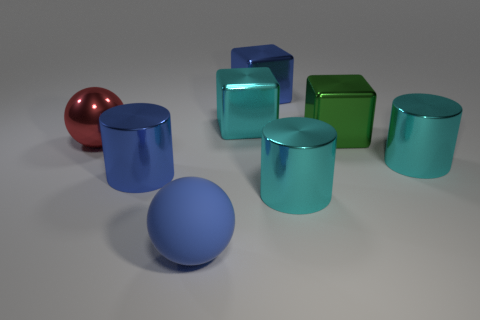Subtract all large cyan cylinders. How many cylinders are left? 1 Subtract 1 cylinders. How many cylinders are left? 2 Add 2 large green matte things. How many objects exist? 10 Subtract all balls. How many objects are left? 6 Add 8 tiny yellow cylinders. How many tiny yellow cylinders exist? 8 Subtract 0 purple balls. How many objects are left? 8 Subtract all blue matte things. Subtract all cyan metal cylinders. How many objects are left? 5 Add 3 large green objects. How many large green objects are left? 4 